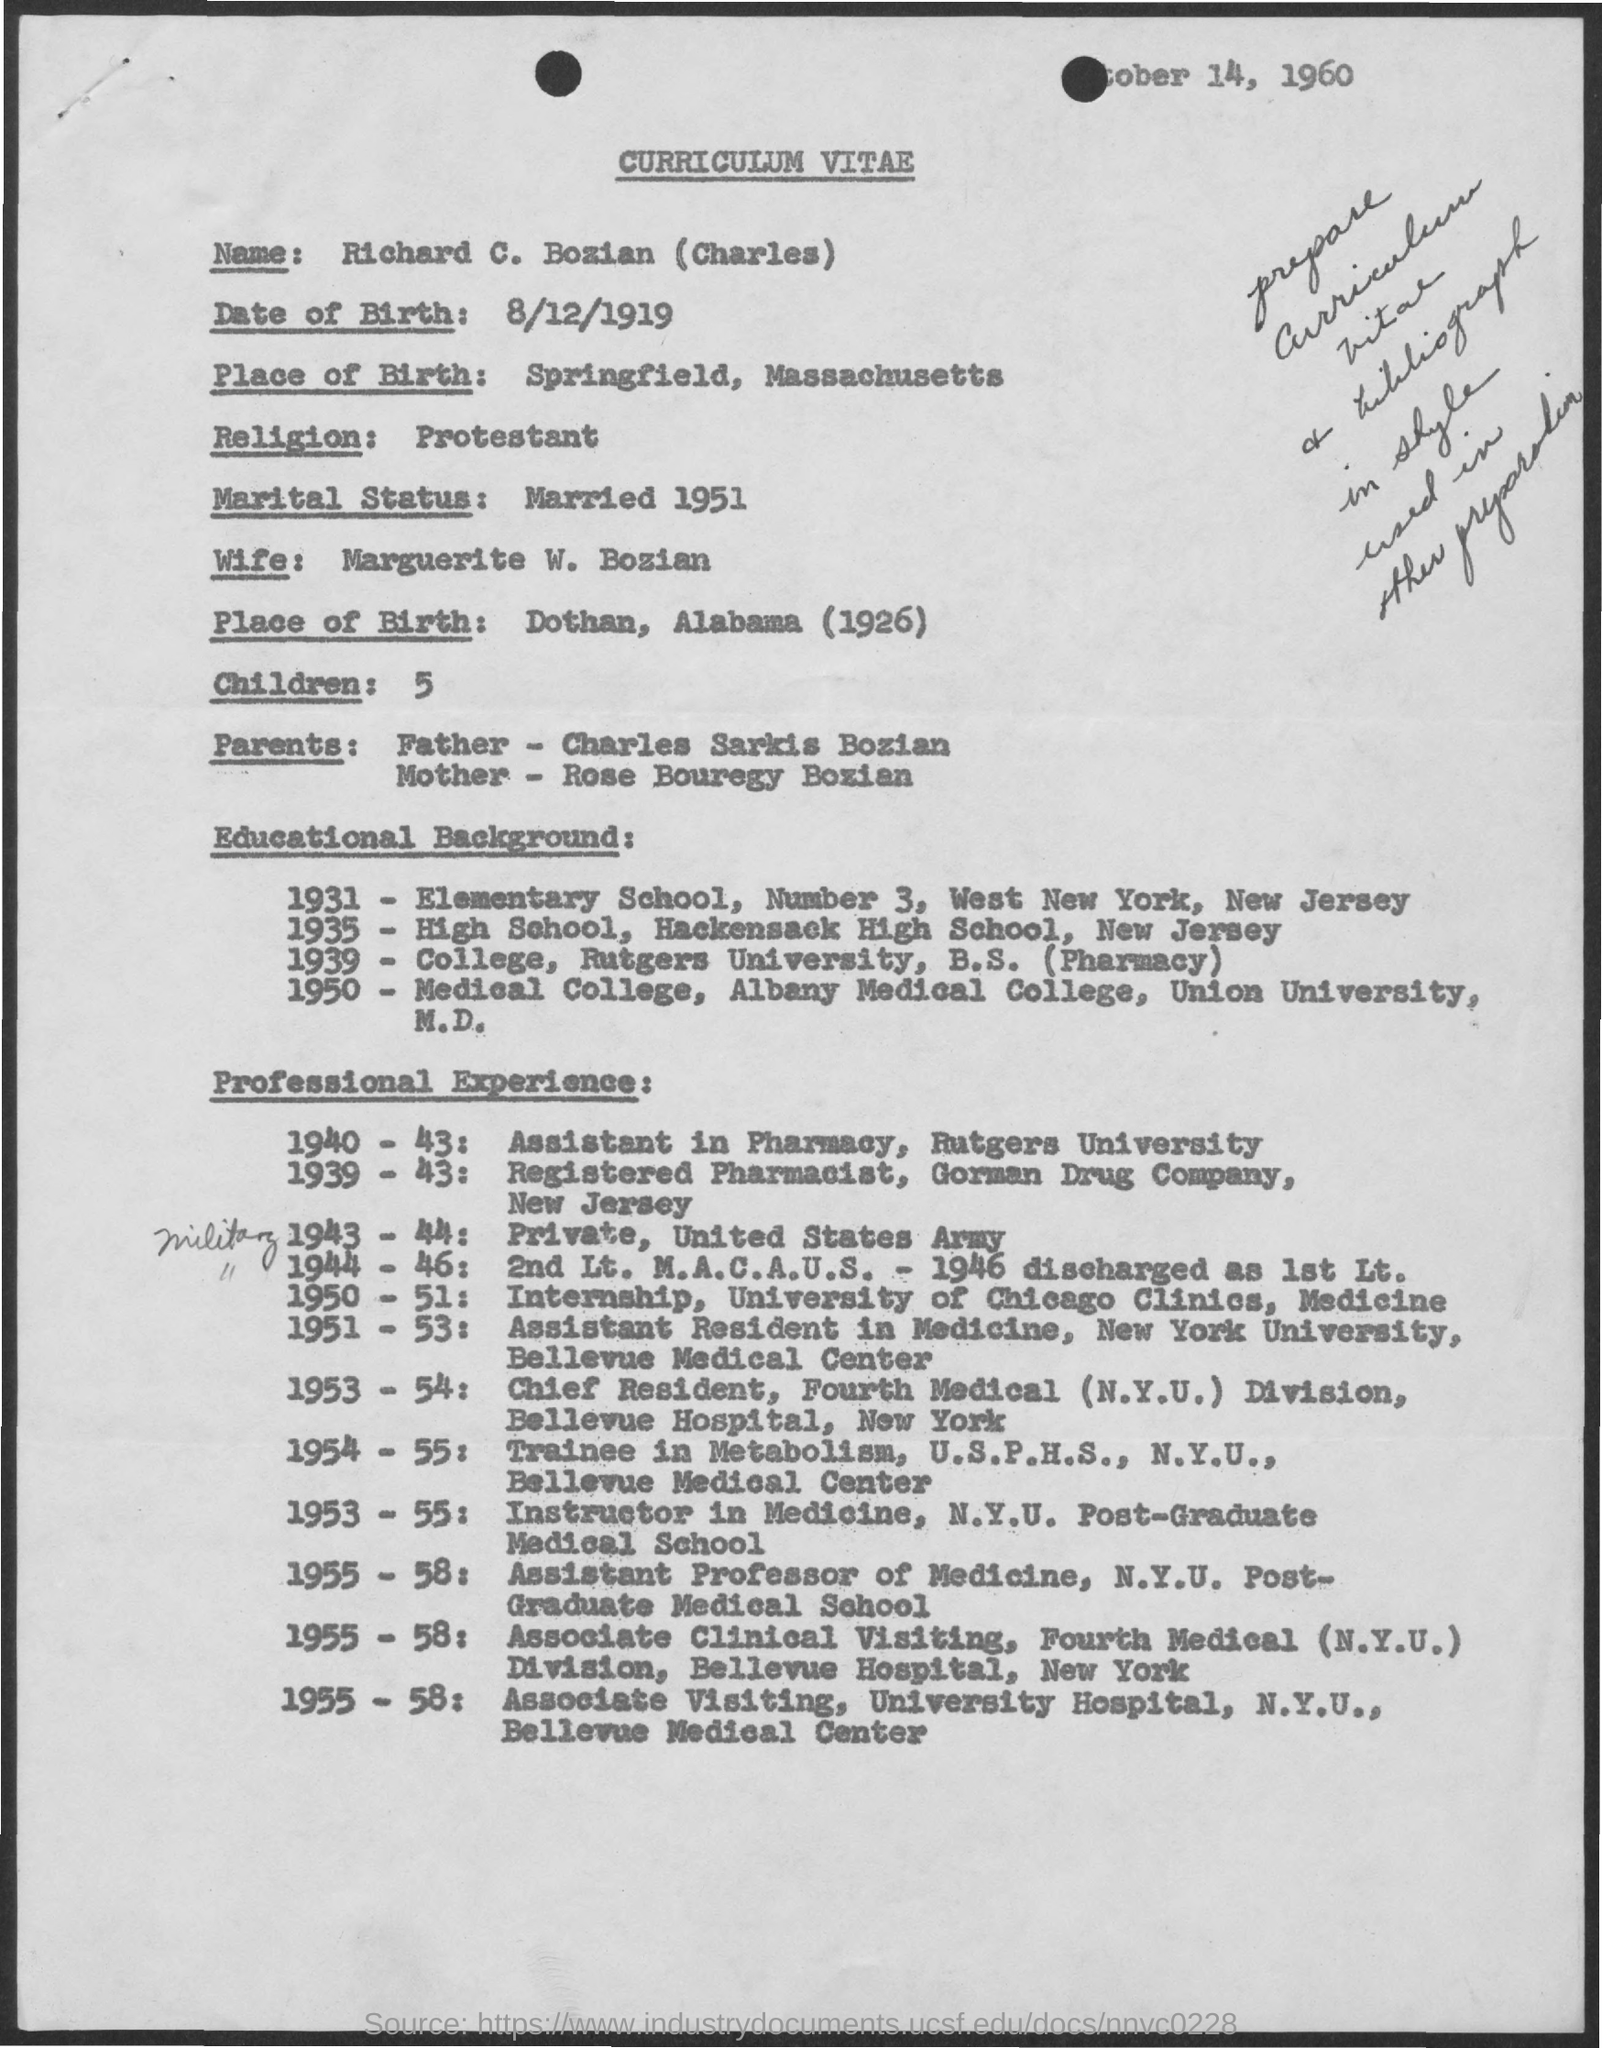What is the title of document?
Your answer should be very brief. Curriculum vitae. What is the alias name of richard c. bozian?
Offer a terse response. Charles. What is date of birth of charles ?
Ensure brevity in your answer.  8/12/1919. What is the religion of charles?
Your answer should be compact. Protestant. What is the name of charles' wife?
Make the answer very short. Marguerite W. Bozian. How many children does charles have?
Make the answer very short. 5. What is the name of charles' father ?
Provide a succinct answer. Charles sarkis bozian. 